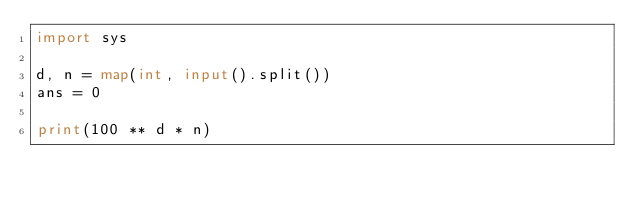<code> <loc_0><loc_0><loc_500><loc_500><_Python_>import sys

d, n = map(int, input().split())
ans = 0

print(100 ** d * n)    
</code> 